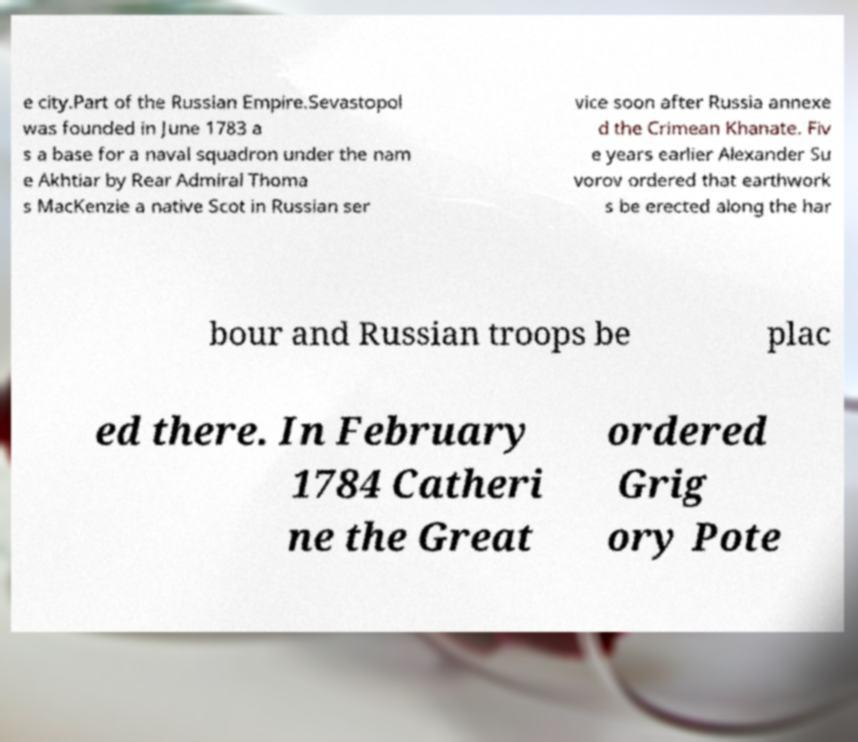Could you extract and type out the text from this image? e city.Part of the Russian Empire.Sevastopol was founded in June 1783 a s a base for a naval squadron under the nam e Akhtiar by Rear Admiral Thoma s MacKenzie a native Scot in Russian ser vice soon after Russia annexe d the Crimean Khanate. Fiv e years earlier Alexander Su vorov ordered that earthwork s be erected along the har bour and Russian troops be plac ed there. In February 1784 Catheri ne the Great ordered Grig ory Pote 